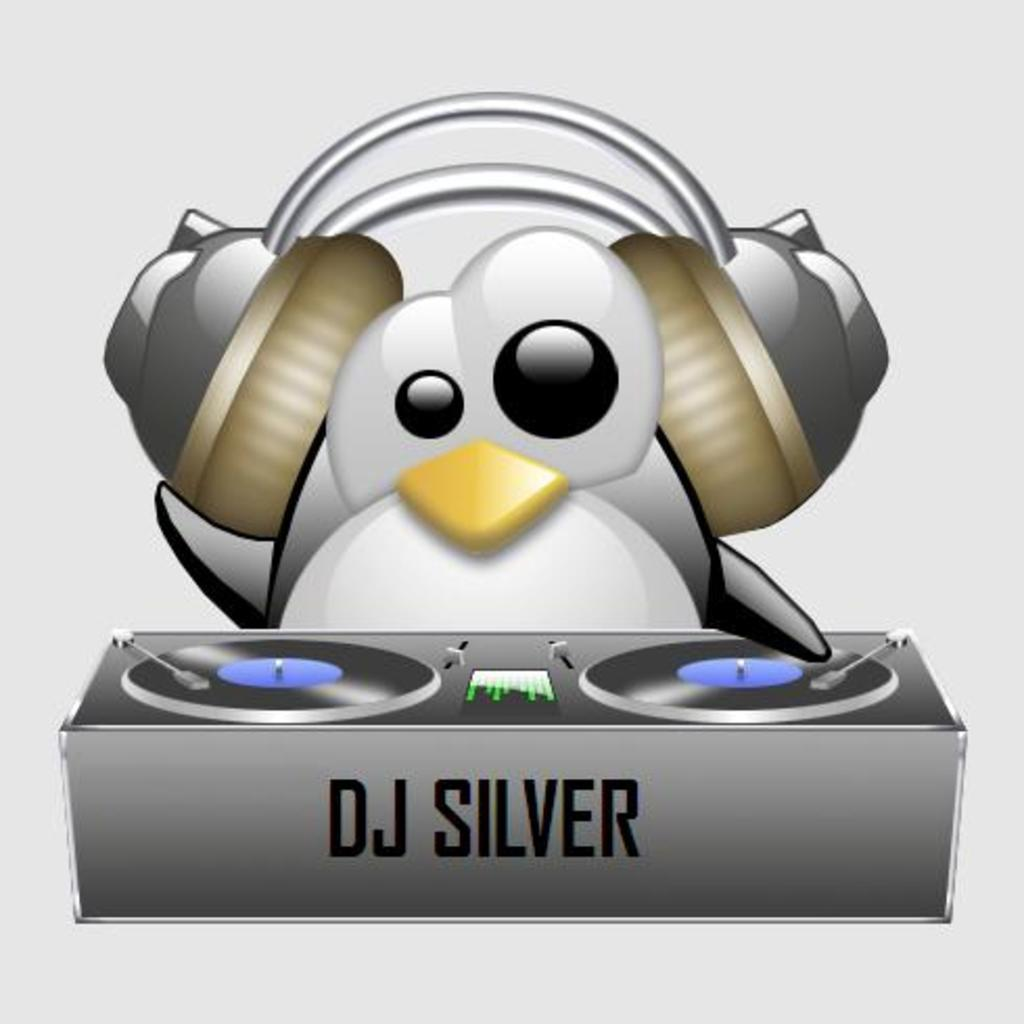What type of picture is in the image? There is a cartoon picture in the image. What device is visible in the image? There is a DJ device in the image. What is the DJ using to listen to music in the image? There is a headset in the image. What color is the background of the image? The background of the image is white. What type of food is being served on the floor in the image? There is no food or floor present in the image; it features a cartoon picture, a headset, and a DJ device with a white background. 